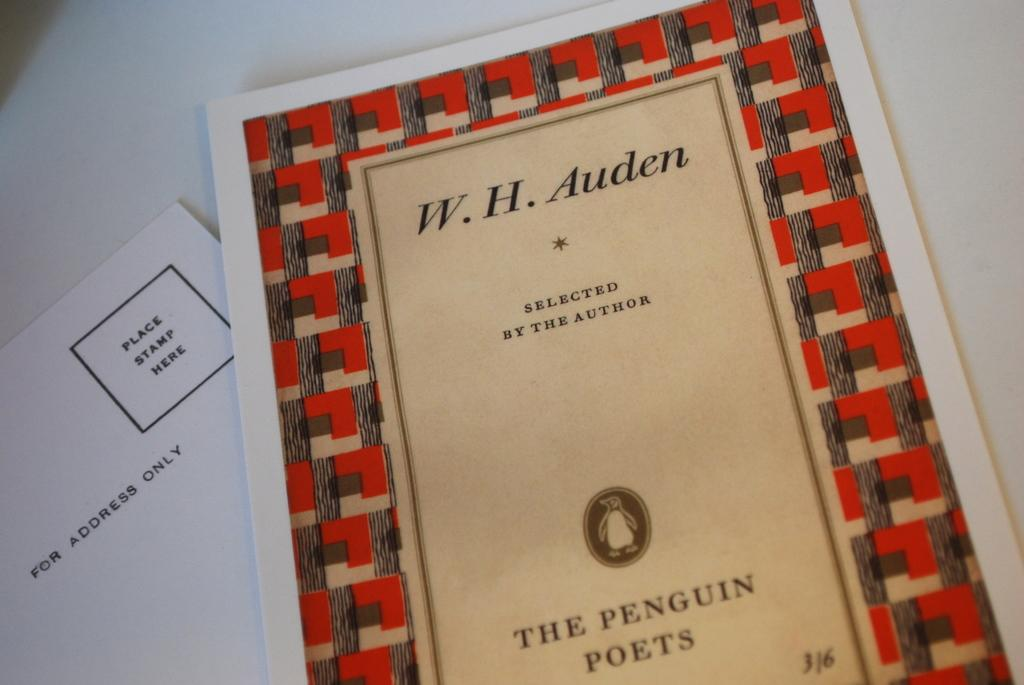<image>
Present a compact description of the photo's key features. A book of selected poems by W.H. Auden is put out by the Penguin Poets. 